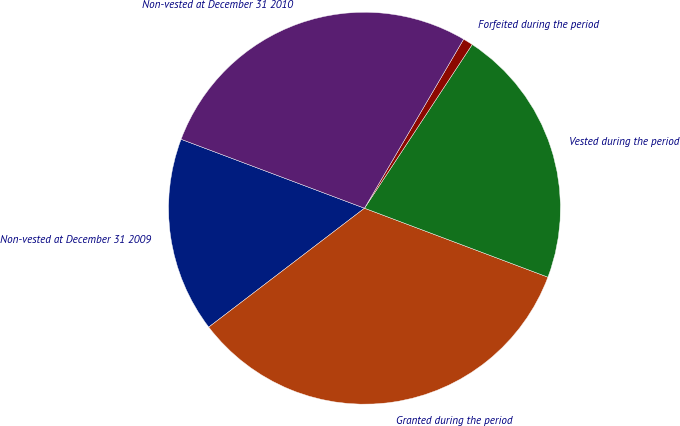Convert chart to OTSL. <chart><loc_0><loc_0><loc_500><loc_500><pie_chart><fcel>Non-vested at December 31 2009<fcel>Granted during the period<fcel>Vested during the period<fcel>Forfeited during the period<fcel>Non-vested at December 31 2010<nl><fcel>16.1%<fcel>33.9%<fcel>21.46%<fcel>0.82%<fcel>27.72%<nl></chart> 